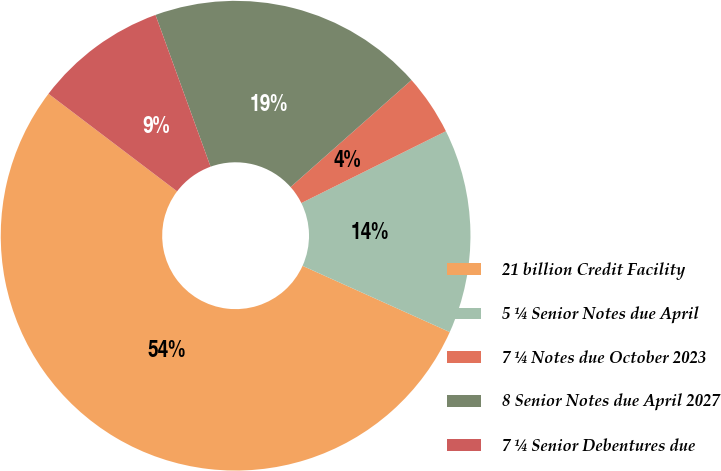Convert chart. <chart><loc_0><loc_0><loc_500><loc_500><pie_chart><fcel>21 billion Credit Facility<fcel>5 ¼ Senior Notes due April<fcel>7 ¼ Notes due October 2023<fcel>8 Senior Notes due April 2027<fcel>7 ¼ Senior Debentures due<nl><fcel>53.6%<fcel>14.07%<fcel>4.19%<fcel>19.01%<fcel>9.13%<nl></chart> 